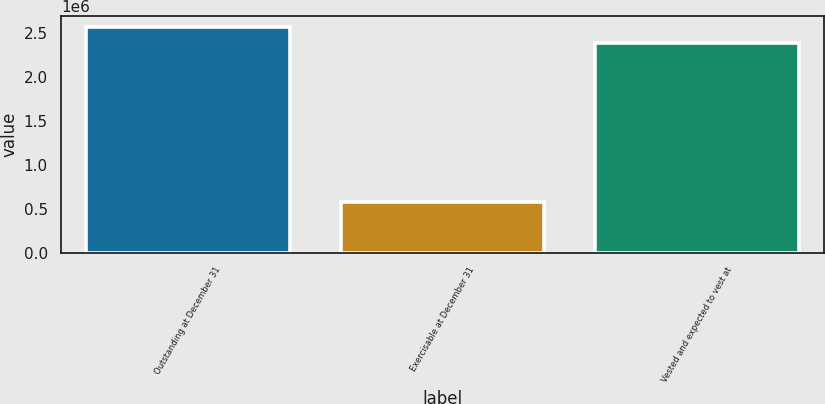Convert chart. <chart><loc_0><loc_0><loc_500><loc_500><bar_chart><fcel>Outstanding at December 31<fcel>Exercisable at December 31<fcel>Vested and expected to vest at<nl><fcel>2.56277e+06<fcel>576963<fcel>2.37836e+06<nl></chart> 